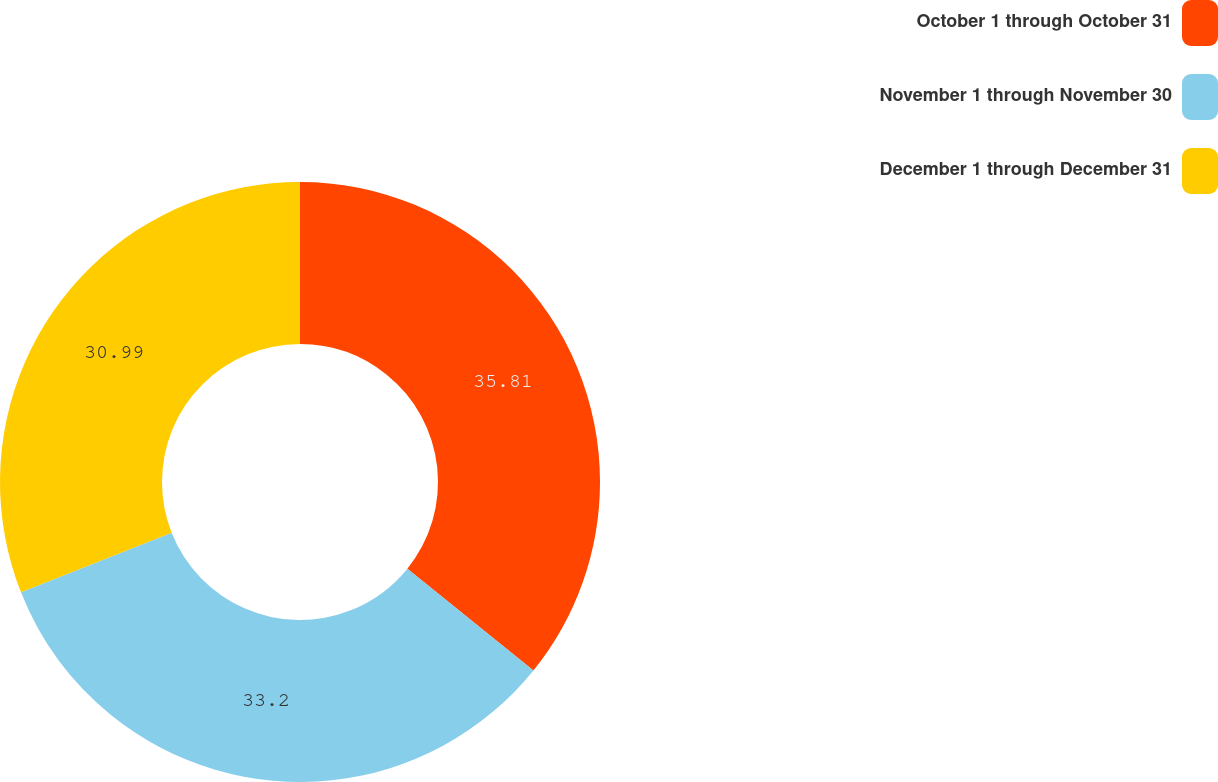<chart> <loc_0><loc_0><loc_500><loc_500><pie_chart><fcel>October 1 through October 31<fcel>November 1 through November 30<fcel>December 1 through December 31<nl><fcel>35.81%<fcel>33.2%<fcel>30.99%<nl></chart> 